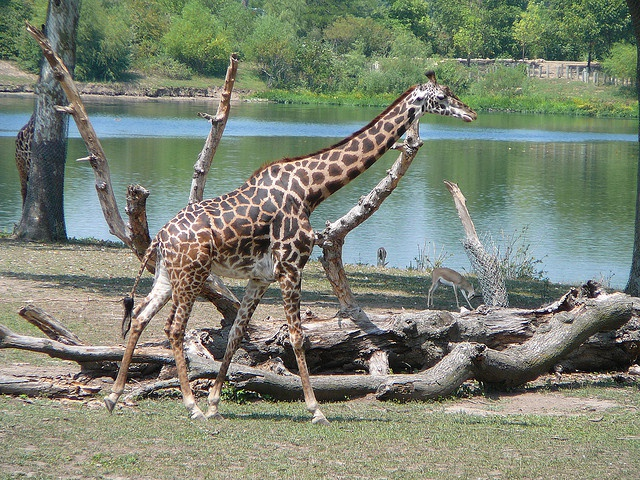Describe the objects in this image and their specific colors. I can see giraffe in black, gray, and darkgray tones and giraffe in black, gray, and darkgreen tones in this image. 